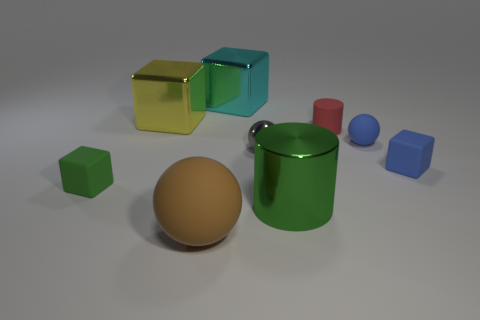Add 1 blue blocks. How many objects exist? 10 Subtract all blocks. How many objects are left? 5 Add 1 yellow spheres. How many yellow spheres exist? 1 Subtract 0 red balls. How many objects are left? 9 Subtract all blue objects. Subtract all metal balls. How many objects are left? 6 Add 8 cylinders. How many cylinders are left? 10 